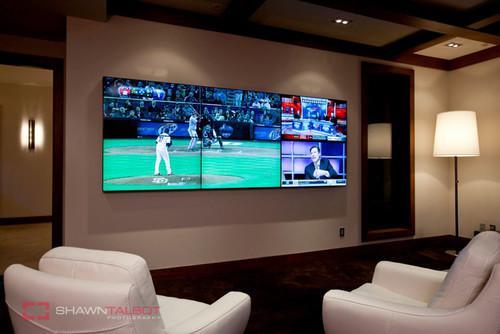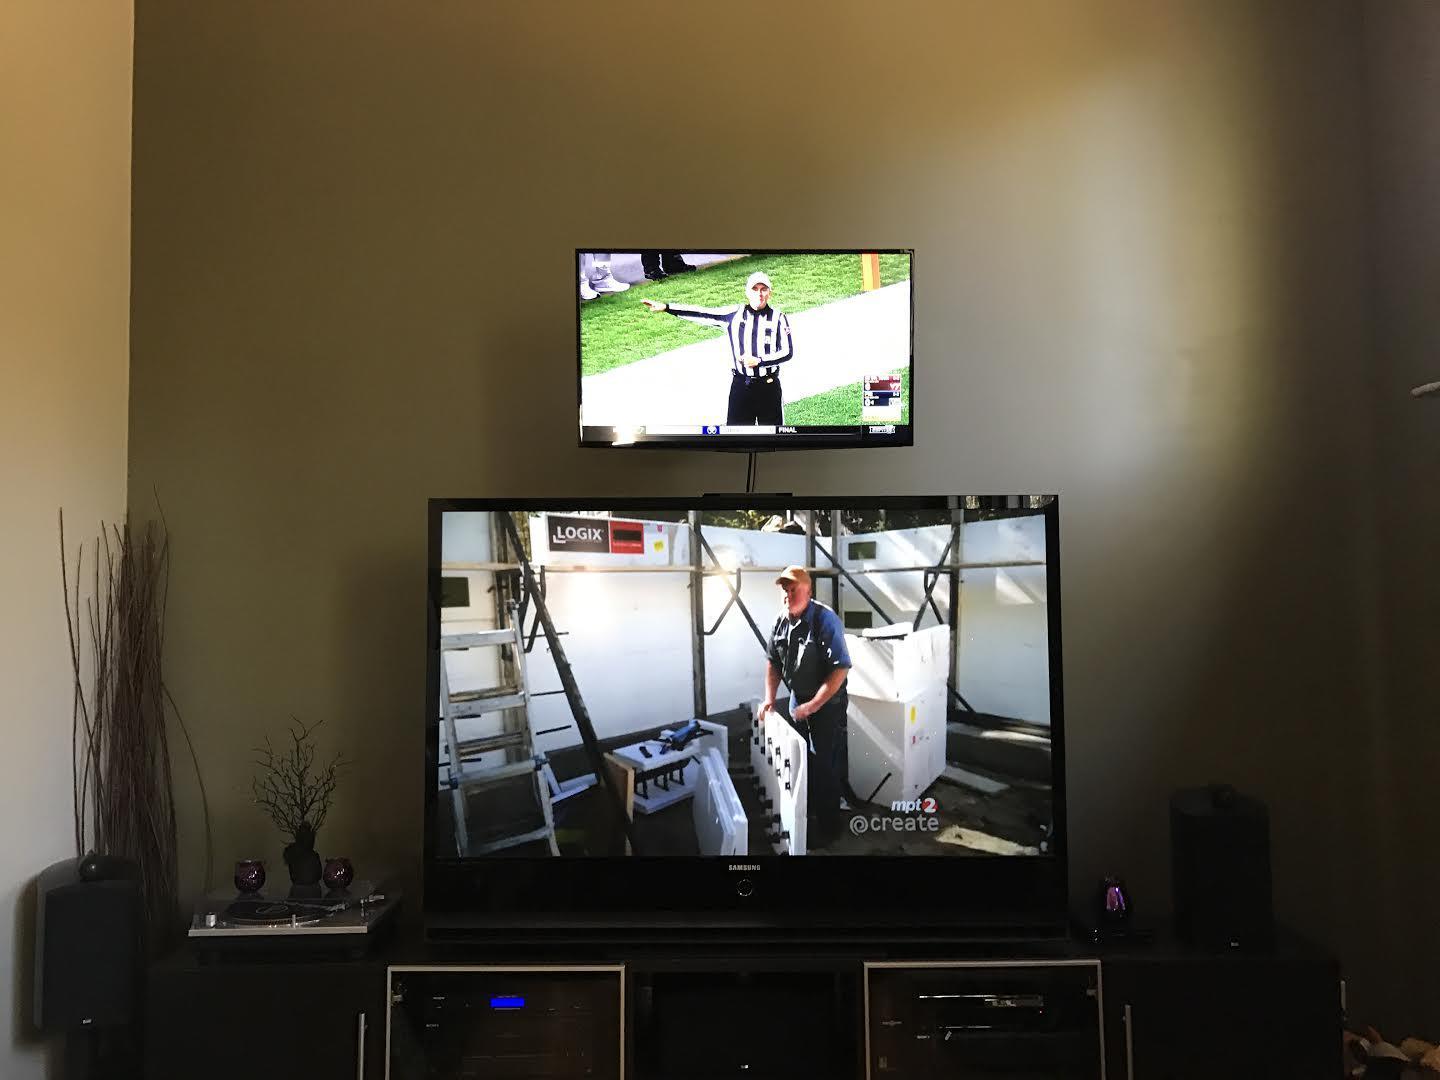The first image is the image on the left, the second image is the image on the right. Considering the images on both sides, is "The right image shows a symmetrical grouping of at least four screens mounted on an inset wall surrounded by brown wood." valid? Answer yes or no. No. The first image is the image on the left, the second image is the image on the right. For the images displayed, is the sentence "Cushioned furniture is positioned near screens mounted on the wall in one of the images." factually correct? Answer yes or no. Yes. 